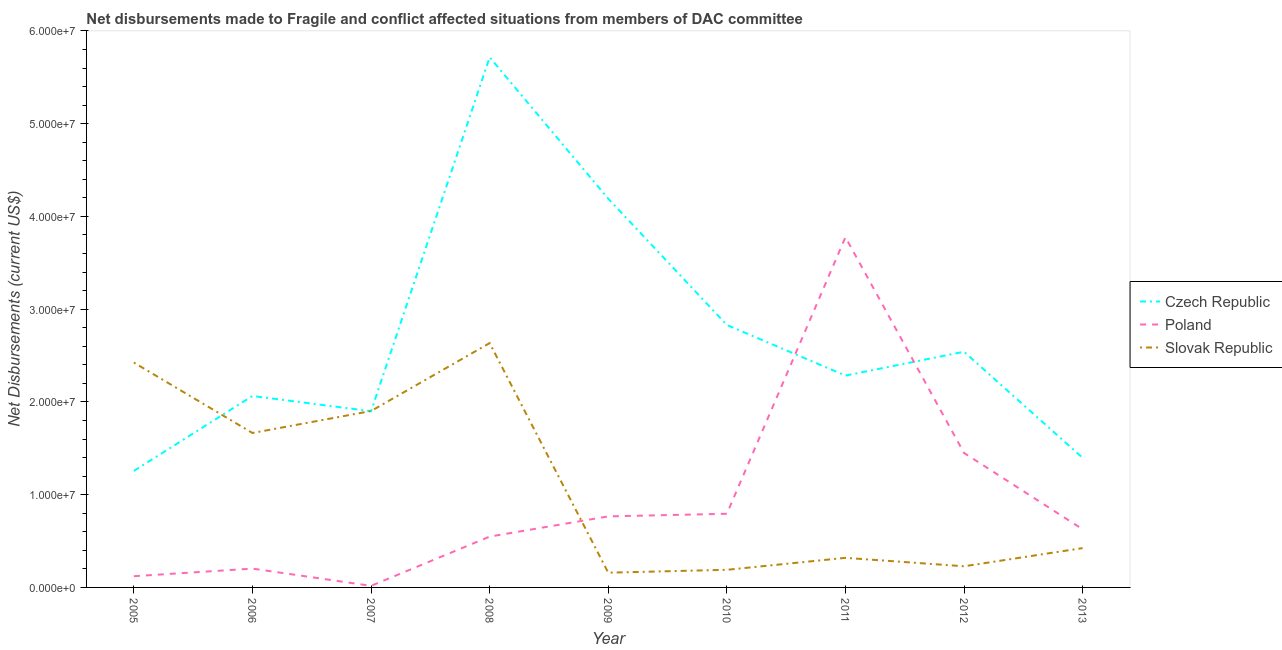How many different coloured lines are there?
Give a very brief answer. 3. Does the line corresponding to net disbursements made by slovak republic intersect with the line corresponding to net disbursements made by poland?
Give a very brief answer. Yes. Is the number of lines equal to the number of legend labels?
Ensure brevity in your answer.  Yes. What is the net disbursements made by slovak republic in 2007?
Your response must be concise. 1.90e+07. Across all years, what is the maximum net disbursements made by poland?
Your answer should be very brief. 3.78e+07. Across all years, what is the minimum net disbursements made by czech republic?
Provide a short and direct response. 1.26e+07. In which year was the net disbursements made by slovak republic maximum?
Your answer should be compact. 2008. What is the total net disbursements made by slovak republic in the graph?
Offer a terse response. 9.94e+07. What is the difference between the net disbursements made by czech republic in 2006 and that in 2007?
Your answer should be compact. 1.64e+06. What is the difference between the net disbursements made by slovak republic in 2008 and the net disbursements made by poland in 2005?
Your answer should be compact. 2.51e+07. What is the average net disbursements made by slovak republic per year?
Your response must be concise. 1.10e+07. In the year 2009, what is the difference between the net disbursements made by poland and net disbursements made by slovak republic?
Your answer should be very brief. 6.07e+06. In how many years, is the net disbursements made by slovak republic greater than 30000000 US$?
Offer a terse response. 0. What is the ratio of the net disbursements made by slovak republic in 2006 to that in 2012?
Offer a terse response. 7.3. What is the difference between the highest and the second highest net disbursements made by slovak republic?
Offer a very short reply. 2.10e+06. What is the difference between the highest and the lowest net disbursements made by czech republic?
Give a very brief answer. 4.46e+07. Is it the case that in every year, the sum of the net disbursements made by czech republic and net disbursements made by poland is greater than the net disbursements made by slovak republic?
Give a very brief answer. No. Is the net disbursements made by poland strictly less than the net disbursements made by czech republic over the years?
Offer a very short reply. No. How many lines are there?
Keep it short and to the point. 3. How many years are there in the graph?
Your response must be concise. 9. Are the values on the major ticks of Y-axis written in scientific E-notation?
Make the answer very short. Yes. Does the graph contain any zero values?
Make the answer very short. No. How are the legend labels stacked?
Keep it short and to the point. Vertical. What is the title of the graph?
Your answer should be very brief. Net disbursements made to Fragile and conflict affected situations from members of DAC committee. What is the label or title of the Y-axis?
Give a very brief answer. Net Disbursements (current US$). What is the Net Disbursements (current US$) of Czech Republic in 2005?
Make the answer very short. 1.26e+07. What is the Net Disbursements (current US$) in Poland in 2005?
Your answer should be compact. 1.21e+06. What is the Net Disbursements (current US$) in Slovak Republic in 2005?
Your answer should be compact. 2.42e+07. What is the Net Disbursements (current US$) in Czech Republic in 2006?
Your answer should be very brief. 2.06e+07. What is the Net Disbursements (current US$) of Poland in 2006?
Make the answer very short. 2.03e+06. What is the Net Disbursements (current US$) of Slovak Republic in 2006?
Give a very brief answer. 1.66e+07. What is the Net Disbursements (current US$) in Czech Republic in 2007?
Your response must be concise. 1.90e+07. What is the Net Disbursements (current US$) of Slovak Republic in 2007?
Ensure brevity in your answer.  1.90e+07. What is the Net Disbursements (current US$) of Czech Republic in 2008?
Your answer should be very brief. 5.72e+07. What is the Net Disbursements (current US$) in Poland in 2008?
Your response must be concise. 5.48e+06. What is the Net Disbursements (current US$) in Slovak Republic in 2008?
Offer a terse response. 2.63e+07. What is the Net Disbursements (current US$) of Czech Republic in 2009?
Your response must be concise. 4.19e+07. What is the Net Disbursements (current US$) of Poland in 2009?
Your response must be concise. 7.66e+06. What is the Net Disbursements (current US$) in Slovak Republic in 2009?
Offer a terse response. 1.59e+06. What is the Net Disbursements (current US$) of Czech Republic in 2010?
Provide a short and direct response. 2.83e+07. What is the Net Disbursements (current US$) of Poland in 2010?
Offer a terse response. 7.94e+06. What is the Net Disbursements (current US$) of Slovak Republic in 2010?
Make the answer very short. 1.90e+06. What is the Net Disbursements (current US$) in Czech Republic in 2011?
Provide a short and direct response. 2.28e+07. What is the Net Disbursements (current US$) in Poland in 2011?
Ensure brevity in your answer.  3.78e+07. What is the Net Disbursements (current US$) of Slovak Republic in 2011?
Offer a very short reply. 3.19e+06. What is the Net Disbursements (current US$) of Czech Republic in 2012?
Your answer should be compact. 2.54e+07. What is the Net Disbursements (current US$) of Poland in 2012?
Your answer should be compact. 1.45e+07. What is the Net Disbursements (current US$) in Slovak Republic in 2012?
Ensure brevity in your answer.  2.28e+06. What is the Net Disbursements (current US$) of Czech Republic in 2013?
Provide a short and direct response. 1.40e+07. What is the Net Disbursements (current US$) of Poland in 2013?
Your answer should be very brief. 6.27e+06. What is the Net Disbursements (current US$) of Slovak Republic in 2013?
Keep it short and to the point. 4.24e+06. Across all years, what is the maximum Net Disbursements (current US$) of Czech Republic?
Give a very brief answer. 5.72e+07. Across all years, what is the maximum Net Disbursements (current US$) in Poland?
Your response must be concise. 3.78e+07. Across all years, what is the maximum Net Disbursements (current US$) in Slovak Republic?
Offer a very short reply. 2.63e+07. Across all years, what is the minimum Net Disbursements (current US$) in Czech Republic?
Offer a terse response. 1.26e+07. Across all years, what is the minimum Net Disbursements (current US$) of Poland?
Your answer should be very brief. 1.70e+05. Across all years, what is the minimum Net Disbursements (current US$) of Slovak Republic?
Provide a short and direct response. 1.59e+06. What is the total Net Disbursements (current US$) of Czech Republic in the graph?
Your answer should be very brief. 2.42e+08. What is the total Net Disbursements (current US$) of Poland in the graph?
Give a very brief answer. 8.30e+07. What is the total Net Disbursements (current US$) in Slovak Republic in the graph?
Provide a succinct answer. 9.94e+07. What is the difference between the Net Disbursements (current US$) of Czech Republic in 2005 and that in 2006?
Keep it short and to the point. -8.08e+06. What is the difference between the Net Disbursements (current US$) in Poland in 2005 and that in 2006?
Offer a terse response. -8.20e+05. What is the difference between the Net Disbursements (current US$) in Slovak Republic in 2005 and that in 2006?
Keep it short and to the point. 7.59e+06. What is the difference between the Net Disbursements (current US$) in Czech Republic in 2005 and that in 2007?
Your answer should be compact. -6.44e+06. What is the difference between the Net Disbursements (current US$) of Poland in 2005 and that in 2007?
Ensure brevity in your answer.  1.04e+06. What is the difference between the Net Disbursements (current US$) in Slovak Republic in 2005 and that in 2007?
Make the answer very short. 5.22e+06. What is the difference between the Net Disbursements (current US$) of Czech Republic in 2005 and that in 2008?
Your answer should be compact. -4.46e+07. What is the difference between the Net Disbursements (current US$) of Poland in 2005 and that in 2008?
Make the answer very short. -4.27e+06. What is the difference between the Net Disbursements (current US$) in Slovak Republic in 2005 and that in 2008?
Provide a succinct answer. -2.10e+06. What is the difference between the Net Disbursements (current US$) in Czech Republic in 2005 and that in 2009?
Your answer should be very brief. -2.94e+07. What is the difference between the Net Disbursements (current US$) in Poland in 2005 and that in 2009?
Offer a terse response. -6.45e+06. What is the difference between the Net Disbursements (current US$) of Slovak Republic in 2005 and that in 2009?
Give a very brief answer. 2.26e+07. What is the difference between the Net Disbursements (current US$) in Czech Republic in 2005 and that in 2010?
Give a very brief answer. -1.57e+07. What is the difference between the Net Disbursements (current US$) of Poland in 2005 and that in 2010?
Your response must be concise. -6.73e+06. What is the difference between the Net Disbursements (current US$) in Slovak Republic in 2005 and that in 2010?
Your answer should be compact. 2.23e+07. What is the difference between the Net Disbursements (current US$) of Czech Republic in 2005 and that in 2011?
Your answer should be very brief. -1.03e+07. What is the difference between the Net Disbursements (current US$) in Poland in 2005 and that in 2011?
Provide a succinct answer. -3.66e+07. What is the difference between the Net Disbursements (current US$) of Slovak Republic in 2005 and that in 2011?
Offer a terse response. 2.10e+07. What is the difference between the Net Disbursements (current US$) in Czech Republic in 2005 and that in 2012?
Offer a very short reply. -1.28e+07. What is the difference between the Net Disbursements (current US$) in Poland in 2005 and that in 2012?
Your response must be concise. -1.33e+07. What is the difference between the Net Disbursements (current US$) in Slovak Republic in 2005 and that in 2012?
Offer a very short reply. 2.20e+07. What is the difference between the Net Disbursements (current US$) in Czech Republic in 2005 and that in 2013?
Keep it short and to the point. -1.41e+06. What is the difference between the Net Disbursements (current US$) of Poland in 2005 and that in 2013?
Give a very brief answer. -5.06e+06. What is the difference between the Net Disbursements (current US$) in Slovak Republic in 2005 and that in 2013?
Offer a very short reply. 2.00e+07. What is the difference between the Net Disbursements (current US$) of Czech Republic in 2006 and that in 2007?
Your answer should be compact. 1.64e+06. What is the difference between the Net Disbursements (current US$) in Poland in 2006 and that in 2007?
Keep it short and to the point. 1.86e+06. What is the difference between the Net Disbursements (current US$) in Slovak Republic in 2006 and that in 2007?
Your answer should be compact. -2.37e+06. What is the difference between the Net Disbursements (current US$) of Czech Republic in 2006 and that in 2008?
Offer a very short reply. -3.65e+07. What is the difference between the Net Disbursements (current US$) in Poland in 2006 and that in 2008?
Provide a succinct answer. -3.45e+06. What is the difference between the Net Disbursements (current US$) in Slovak Republic in 2006 and that in 2008?
Your answer should be compact. -9.69e+06. What is the difference between the Net Disbursements (current US$) of Czech Republic in 2006 and that in 2009?
Keep it short and to the point. -2.13e+07. What is the difference between the Net Disbursements (current US$) in Poland in 2006 and that in 2009?
Your answer should be very brief. -5.63e+06. What is the difference between the Net Disbursements (current US$) in Slovak Republic in 2006 and that in 2009?
Keep it short and to the point. 1.51e+07. What is the difference between the Net Disbursements (current US$) in Czech Republic in 2006 and that in 2010?
Give a very brief answer. -7.66e+06. What is the difference between the Net Disbursements (current US$) in Poland in 2006 and that in 2010?
Ensure brevity in your answer.  -5.91e+06. What is the difference between the Net Disbursements (current US$) in Slovak Republic in 2006 and that in 2010?
Ensure brevity in your answer.  1.48e+07. What is the difference between the Net Disbursements (current US$) in Czech Republic in 2006 and that in 2011?
Offer a terse response. -2.20e+06. What is the difference between the Net Disbursements (current US$) of Poland in 2006 and that in 2011?
Provide a succinct answer. -3.57e+07. What is the difference between the Net Disbursements (current US$) of Slovak Republic in 2006 and that in 2011?
Provide a succinct answer. 1.35e+07. What is the difference between the Net Disbursements (current US$) in Czech Republic in 2006 and that in 2012?
Keep it short and to the point. -4.77e+06. What is the difference between the Net Disbursements (current US$) of Poland in 2006 and that in 2012?
Your response must be concise. -1.25e+07. What is the difference between the Net Disbursements (current US$) in Slovak Republic in 2006 and that in 2012?
Ensure brevity in your answer.  1.44e+07. What is the difference between the Net Disbursements (current US$) in Czech Republic in 2006 and that in 2013?
Ensure brevity in your answer.  6.67e+06. What is the difference between the Net Disbursements (current US$) of Poland in 2006 and that in 2013?
Offer a terse response. -4.24e+06. What is the difference between the Net Disbursements (current US$) in Slovak Republic in 2006 and that in 2013?
Keep it short and to the point. 1.24e+07. What is the difference between the Net Disbursements (current US$) in Czech Republic in 2007 and that in 2008?
Your answer should be very brief. -3.82e+07. What is the difference between the Net Disbursements (current US$) in Poland in 2007 and that in 2008?
Offer a terse response. -5.31e+06. What is the difference between the Net Disbursements (current US$) of Slovak Republic in 2007 and that in 2008?
Provide a short and direct response. -7.32e+06. What is the difference between the Net Disbursements (current US$) in Czech Republic in 2007 and that in 2009?
Your answer should be compact. -2.29e+07. What is the difference between the Net Disbursements (current US$) in Poland in 2007 and that in 2009?
Ensure brevity in your answer.  -7.49e+06. What is the difference between the Net Disbursements (current US$) in Slovak Republic in 2007 and that in 2009?
Provide a short and direct response. 1.74e+07. What is the difference between the Net Disbursements (current US$) in Czech Republic in 2007 and that in 2010?
Your answer should be very brief. -9.30e+06. What is the difference between the Net Disbursements (current US$) in Poland in 2007 and that in 2010?
Give a very brief answer. -7.77e+06. What is the difference between the Net Disbursements (current US$) in Slovak Republic in 2007 and that in 2010?
Provide a succinct answer. 1.71e+07. What is the difference between the Net Disbursements (current US$) of Czech Republic in 2007 and that in 2011?
Provide a succinct answer. -3.84e+06. What is the difference between the Net Disbursements (current US$) of Poland in 2007 and that in 2011?
Ensure brevity in your answer.  -3.76e+07. What is the difference between the Net Disbursements (current US$) of Slovak Republic in 2007 and that in 2011?
Provide a short and direct response. 1.58e+07. What is the difference between the Net Disbursements (current US$) of Czech Republic in 2007 and that in 2012?
Offer a terse response. -6.41e+06. What is the difference between the Net Disbursements (current US$) in Poland in 2007 and that in 2012?
Ensure brevity in your answer.  -1.43e+07. What is the difference between the Net Disbursements (current US$) in Slovak Republic in 2007 and that in 2012?
Provide a short and direct response. 1.67e+07. What is the difference between the Net Disbursements (current US$) of Czech Republic in 2007 and that in 2013?
Provide a succinct answer. 5.03e+06. What is the difference between the Net Disbursements (current US$) of Poland in 2007 and that in 2013?
Offer a very short reply. -6.10e+06. What is the difference between the Net Disbursements (current US$) in Slovak Republic in 2007 and that in 2013?
Your response must be concise. 1.48e+07. What is the difference between the Net Disbursements (current US$) in Czech Republic in 2008 and that in 2009?
Your response must be concise. 1.52e+07. What is the difference between the Net Disbursements (current US$) of Poland in 2008 and that in 2009?
Provide a short and direct response. -2.18e+06. What is the difference between the Net Disbursements (current US$) of Slovak Republic in 2008 and that in 2009?
Offer a very short reply. 2.48e+07. What is the difference between the Net Disbursements (current US$) of Czech Republic in 2008 and that in 2010?
Make the answer very short. 2.89e+07. What is the difference between the Net Disbursements (current US$) in Poland in 2008 and that in 2010?
Your answer should be very brief. -2.46e+06. What is the difference between the Net Disbursements (current US$) in Slovak Republic in 2008 and that in 2010?
Make the answer very short. 2.44e+07. What is the difference between the Net Disbursements (current US$) in Czech Republic in 2008 and that in 2011?
Keep it short and to the point. 3.43e+07. What is the difference between the Net Disbursements (current US$) of Poland in 2008 and that in 2011?
Offer a terse response. -3.23e+07. What is the difference between the Net Disbursements (current US$) of Slovak Republic in 2008 and that in 2011?
Offer a very short reply. 2.32e+07. What is the difference between the Net Disbursements (current US$) in Czech Republic in 2008 and that in 2012?
Your response must be concise. 3.18e+07. What is the difference between the Net Disbursements (current US$) of Poland in 2008 and that in 2012?
Give a very brief answer. -9.02e+06. What is the difference between the Net Disbursements (current US$) of Slovak Republic in 2008 and that in 2012?
Your response must be concise. 2.41e+07. What is the difference between the Net Disbursements (current US$) in Czech Republic in 2008 and that in 2013?
Offer a very short reply. 4.32e+07. What is the difference between the Net Disbursements (current US$) in Poland in 2008 and that in 2013?
Your answer should be very brief. -7.90e+05. What is the difference between the Net Disbursements (current US$) in Slovak Republic in 2008 and that in 2013?
Your answer should be compact. 2.21e+07. What is the difference between the Net Disbursements (current US$) of Czech Republic in 2009 and that in 2010?
Your answer should be very brief. 1.36e+07. What is the difference between the Net Disbursements (current US$) in Poland in 2009 and that in 2010?
Your response must be concise. -2.80e+05. What is the difference between the Net Disbursements (current US$) of Slovak Republic in 2009 and that in 2010?
Ensure brevity in your answer.  -3.10e+05. What is the difference between the Net Disbursements (current US$) of Czech Republic in 2009 and that in 2011?
Your response must be concise. 1.91e+07. What is the difference between the Net Disbursements (current US$) of Poland in 2009 and that in 2011?
Make the answer very short. -3.01e+07. What is the difference between the Net Disbursements (current US$) of Slovak Republic in 2009 and that in 2011?
Provide a succinct answer. -1.60e+06. What is the difference between the Net Disbursements (current US$) of Czech Republic in 2009 and that in 2012?
Keep it short and to the point. 1.65e+07. What is the difference between the Net Disbursements (current US$) in Poland in 2009 and that in 2012?
Ensure brevity in your answer.  -6.84e+06. What is the difference between the Net Disbursements (current US$) in Slovak Republic in 2009 and that in 2012?
Give a very brief answer. -6.90e+05. What is the difference between the Net Disbursements (current US$) in Czech Republic in 2009 and that in 2013?
Ensure brevity in your answer.  2.79e+07. What is the difference between the Net Disbursements (current US$) in Poland in 2009 and that in 2013?
Provide a succinct answer. 1.39e+06. What is the difference between the Net Disbursements (current US$) of Slovak Republic in 2009 and that in 2013?
Provide a short and direct response. -2.65e+06. What is the difference between the Net Disbursements (current US$) of Czech Republic in 2010 and that in 2011?
Your response must be concise. 5.46e+06. What is the difference between the Net Disbursements (current US$) in Poland in 2010 and that in 2011?
Provide a short and direct response. -2.98e+07. What is the difference between the Net Disbursements (current US$) in Slovak Republic in 2010 and that in 2011?
Provide a short and direct response. -1.29e+06. What is the difference between the Net Disbursements (current US$) of Czech Republic in 2010 and that in 2012?
Offer a very short reply. 2.89e+06. What is the difference between the Net Disbursements (current US$) in Poland in 2010 and that in 2012?
Your answer should be compact. -6.56e+06. What is the difference between the Net Disbursements (current US$) of Slovak Republic in 2010 and that in 2012?
Provide a succinct answer. -3.80e+05. What is the difference between the Net Disbursements (current US$) in Czech Republic in 2010 and that in 2013?
Provide a succinct answer. 1.43e+07. What is the difference between the Net Disbursements (current US$) in Poland in 2010 and that in 2013?
Offer a terse response. 1.67e+06. What is the difference between the Net Disbursements (current US$) in Slovak Republic in 2010 and that in 2013?
Make the answer very short. -2.34e+06. What is the difference between the Net Disbursements (current US$) in Czech Republic in 2011 and that in 2012?
Offer a very short reply. -2.57e+06. What is the difference between the Net Disbursements (current US$) of Poland in 2011 and that in 2012?
Offer a very short reply. 2.33e+07. What is the difference between the Net Disbursements (current US$) in Slovak Republic in 2011 and that in 2012?
Your answer should be compact. 9.10e+05. What is the difference between the Net Disbursements (current US$) in Czech Republic in 2011 and that in 2013?
Your answer should be compact. 8.87e+06. What is the difference between the Net Disbursements (current US$) in Poland in 2011 and that in 2013?
Your response must be concise. 3.15e+07. What is the difference between the Net Disbursements (current US$) in Slovak Republic in 2011 and that in 2013?
Make the answer very short. -1.05e+06. What is the difference between the Net Disbursements (current US$) of Czech Republic in 2012 and that in 2013?
Your answer should be very brief. 1.14e+07. What is the difference between the Net Disbursements (current US$) of Poland in 2012 and that in 2013?
Provide a succinct answer. 8.23e+06. What is the difference between the Net Disbursements (current US$) in Slovak Republic in 2012 and that in 2013?
Keep it short and to the point. -1.96e+06. What is the difference between the Net Disbursements (current US$) of Czech Republic in 2005 and the Net Disbursements (current US$) of Poland in 2006?
Offer a very short reply. 1.05e+07. What is the difference between the Net Disbursements (current US$) of Czech Republic in 2005 and the Net Disbursements (current US$) of Slovak Republic in 2006?
Your answer should be very brief. -4.09e+06. What is the difference between the Net Disbursements (current US$) of Poland in 2005 and the Net Disbursements (current US$) of Slovak Republic in 2006?
Ensure brevity in your answer.  -1.54e+07. What is the difference between the Net Disbursements (current US$) of Czech Republic in 2005 and the Net Disbursements (current US$) of Poland in 2007?
Offer a very short reply. 1.24e+07. What is the difference between the Net Disbursements (current US$) of Czech Republic in 2005 and the Net Disbursements (current US$) of Slovak Republic in 2007?
Your response must be concise. -6.46e+06. What is the difference between the Net Disbursements (current US$) in Poland in 2005 and the Net Disbursements (current US$) in Slovak Republic in 2007?
Offer a terse response. -1.78e+07. What is the difference between the Net Disbursements (current US$) in Czech Republic in 2005 and the Net Disbursements (current US$) in Poland in 2008?
Your answer should be compact. 7.08e+06. What is the difference between the Net Disbursements (current US$) in Czech Republic in 2005 and the Net Disbursements (current US$) in Slovak Republic in 2008?
Offer a terse response. -1.38e+07. What is the difference between the Net Disbursements (current US$) in Poland in 2005 and the Net Disbursements (current US$) in Slovak Republic in 2008?
Give a very brief answer. -2.51e+07. What is the difference between the Net Disbursements (current US$) in Czech Republic in 2005 and the Net Disbursements (current US$) in Poland in 2009?
Provide a short and direct response. 4.90e+06. What is the difference between the Net Disbursements (current US$) in Czech Republic in 2005 and the Net Disbursements (current US$) in Slovak Republic in 2009?
Keep it short and to the point. 1.10e+07. What is the difference between the Net Disbursements (current US$) in Poland in 2005 and the Net Disbursements (current US$) in Slovak Republic in 2009?
Ensure brevity in your answer.  -3.80e+05. What is the difference between the Net Disbursements (current US$) in Czech Republic in 2005 and the Net Disbursements (current US$) in Poland in 2010?
Offer a very short reply. 4.62e+06. What is the difference between the Net Disbursements (current US$) in Czech Republic in 2005 and the Net Disbursements (current US$) in Slovak Republic in 2010?
Give a very brief answer. 1.07e+07. What is the difference between the Net Disbursements (current US$) in Poland in 2005 and the Net Disbursements (current US$) in Slovak Republic in 2010?
Make the answer very short. -6.90e+05. What is the difference between the Net Disbursements (current US$) in Czech Republic in 2005 and the Net Disbursements (current US$) in Poland in 2011?
Make the answer very short. -2.52e+07. What is the difference between the Net Disbursements (current US$) of Czech Republic in 2005 and the Net Disbursements (current US$) of Slovak Republic in 2011?
Provide a short and direct response. 9.37e+06. What is the difference between the Net Disbursements (current US$) of Poland in 2005 and the Net Disbursements (current US$) of Slovak Republic in 2011?
Provide a short and direct response. -1.98e+06. What is the difference between the Net Disbursements (current US$) in Czech Republic in 2005 and the Net Disbursements (current US$) in Poland in 2012?
Your answer should be very brief. -1.94e+06. What is the difference between the Net Disbursements (current US$) of Czech Republic in 2005 and the Net Disbursements (current US$) of Slovak Republic in 2012?
Keep it short and to the point. 1.03e+07. What is the difference between the Net Disbursements (current US$) of Poland in 2005 and the Net Disbursements (current US$) of Slovak Republic in 2012?
Offer a terse response. -1.07e+06. What is the difference between the Net Disbursements (current US$) in Czech Republic in 2005 and the Net Disbursements (current US$) in Poland in 2013?
Your response must be concise. 6.29e+06. What is the difference between the Net Disbursements (current US$) of Czech Republic in 2005 and the Net Disbursements (current US$) of Slovak Republic in 2013?
Provide a succinct answer. 8.32e+06. What is the difference between the Net Disbursements (current US$) of Poland in 2005 and the Net Disbursements (current US$) of Slovak Republic in 2013?
Keep it short and to the point. -3.03e+06. What is the difference between the Net Disbursements (current US$) of Czech Republic in 2006 and the Net Disbursements (current US$) of Poland in 2007?
Keep it short and to the point. 2.05e+07. What is the difference between the Net Disbursements (current US$) in Czech Republic in 2006 and the Net Disbursements (current US$) in Slovak Republic in 2007?
Your answer should be very brief. 1.62e+06. What is the difference between the Net Disbursements (current US$) of Poland in 2006 and the Net Disbursements (current US$) of Slovak Republic in 2007?
Provide a short and direct response. -1.70e+07. What is the difference between the Net Disbursements (current US$) of Czech Republic in 2006 and the Net Disbursements (current US$) of Poland in 2008?
Offer a terse response. 1.52e+07. What is the difference between the Net Disbursements (current US$) of Czech Republic in 2006 and the Net Disbursements (current US$) of Slovak Republic in 2008?
Offer a very short reply. -5.70e+06. What is the difference between the Net Disbursements (current US$) of Poland in 2006 and the Net Disbursements (current US$) of Slovak Republic in 2008?
Your answer should be very brief. -2.43e+07. What is the difference between the Net Disbursements (current US$) of Czech Republic in 2006 and the Net Disbursements (current US$) of Poland in 2009?
Your answer should be compact. 1.30e+07. What is the difference between the Net Disbursements (current US$) of Czech Republic in 2006 and the Net Disbursements (current US$) of Slovak Republic in 2009?
Your answer should be compact. 1.90e+07. What is the difference between the Net Disbursements (current US$) of Czech Republic in 2006 and the Net Disbursements (current US$) of Poland in 2010?
Offer a very short reply. 1.27e+07. What is the difference between the Net Disbursements (current US$) of Czech Republic in 2006 and the Net Disbursements (current US$) of Slovak Republic in 2010?
Your response must be concise. 1.87e+07. What is the difference between the Net Disbursements (current US$) in Poland in 2006 and the Net Disbursements (current US$) in Slovak Republic in 2010?
Offer a terse response. 1.30e+05. What is the difference between the Net Disbursements (current US$) in Czech Republic in 2006 and the Net Disbursements (current US$) in Poland in 2011?
Your answer should be compact. -1.71e+07. What is the difference between the Net Disbursements (current US$) in Czech Republic in 2006 and the Net Disbursements (current US$) in Slovak Republic in 2011?
Your answer should be compact. 1.74e+07. What is the difference between the Net Disbursements (current US$) in Poland in 2006 and the Net Disbursements (current US$) in Slovak Republic in 2011?
Your answer should be compact. -1.16e+06. What is the difference between the Net Disbursements (current US$) of Czech Republic in 2006 and the Net Disbursements (current US$) of Poland in 2012?
Keep it short and to the point. 6.14e+06. What is the difference between the Net Disbursements (current US$) in Czech Republic in 2006 and the Net Disbursements (current US$) in Slovak Republic in 2012?
Offer a terse response. 1.84e+07. What is the difference between the Net Disbursements (current US$) in Czech Republic in 2006 and the Net Disbursements (current US$) in Poland in 2013?
Make the answer very short. 1.44e+07. What is the difference between the Net Disbursements (current US$) in Czech Republic in 2006 and the Net Disbursements (current US$) in Slovak Republic in 2013?
Ensure brevity in your answer.  1.64e+07. What is the difference between the Net Disbursements (current US$) in Poland in 2006 and the Net Disbursements (current US$) in Slovak Republic in 2013?
Give a very brief answer. -2.21e+06. What is the difference between the Net Disbursements (current US$) of Czech Republic in 2007 and the Net Disbursements (current US$) of Poland in 2008?
Provide a succinct answer. 1.35e+07. What is the difference between the Net Disbursements (current US$) in Czech Republic in 2007 and the Net Disbursements (current US$) in Slovak Republic in 2008?
Make the answer very short. -7.34e+06. What is the difference between the Net Disbursements (current US$) of Poland in 2007 and the Net Disbursements (current US$) of Slovak Republic in 2008?
Give a very brief answer. -2.62e+07. What is the difference between the Net Disbursements (current US$) in Czech Republic in 2007 and the Net Disbursements (current US$) in Poland in 2009?
Give a very brief answer. 1.13e+07. What is the difference between the Net Disbursements (current US$) of Czech Republic in 2007 and the Net Disbursements (current US$) of Slovak Republic in 2009?
Give a very brief answer. 1.74e+07. What is the difference between the Net Disbursements (current US$) of Poland in 2007 and the Net Disbursements (current US$) of Slovak Republic in 2009?
Your answer should be very brief. -1.42e+06. What is the difference between the Net Disbursements (current US$) in Czech Republic in 2007 and the Net Disbursements (current US$) in Poland in 2010?
Your response must be concise. 1.11e+07. What is the difference between the Net Disbursements (current US$) of Czech Republic in 2007 and the Net Disbursements (current US$) of Slovak Republic in 2010?
Offer a terse response. 1.71e+07. What is the difference between the Net Disbursements (current US$) in Poland in 2007 and the Net Disbursements (current US$) in Slovak Republic in 2010?
Your answer should be very brief. -1.73e+06. What is the difference between the Net Disbursements (current US$) in Czech Republic in 2007 and the Net Disbursements (current US$) in Poland in 2011?
Your response must be concise. -1.88e+07. What is the difference between the Net Disbursements (current US$) in Czech Republic in 2007 and the Net Disbursements (current US$) in Slovak Republic in 2011?
Keep it short and to the point. 1.58e+07. What is the difference between the Net Disbursements (current US$) of Poland in 2007 and the Net Disbursements (current US$) of Slovak Republic in 2011?
Provide a short and direct response. -3.02e+06. What is the difference between the Net Disbursements (current US$) of Czech Republic in 2007 and the Net Disbursements (current US$) of Poland in 2012?
Make the answer very short. 4.50e+06. What is the difference between the Net Disbursements (current US$) of Czech Republic in 2007 and the Net Disbursements (current US$) of Slovak Republic in 2012?
Ensure brevity in your answer.  1.67e+07. What is the difference between the Net Disbursements (current US$) of Poland in 2007 and the Net Disbursements (current US$) of Slovak Republic in 2012?
Your answer should be compact. -2.11e+06. What is the difference between the Net Disbursements (current US$) in Czech Republic in 2007 and the Net Disbursements (current US$) in Poland in 2013?
Offer a very short reply. 1.27e+07. What is the difference between the Net Disbursements (current US$) of Czech Republic in 2007 and the Net Disbursements (current US$) of Slovak Republic in 2013?
Ensure brevity in your answer.  1.48e+07. What is the difference between the Net Disbursements (current US$) of Poland in 2007 and the Net Disbursements (current US$) of Slovak Republic in 2013?
Your response must be concise. -4.07e+06. What is the difference between the Net Disbursements (current US$) in Czech Republic in 2008 and the Net Disbursements (current US$) in Poland in 2009?
Your answer should be compact. 4.95e+07. What is the difference between the Net Disbursements (current US$) in Czech Republic in 2008 and the Net Disbursements (current US$) in Slovak Republic in 2009?
Ensure brevity in your answer.  5.56e+07. What is the difference between the Net Disbursements (current US$) of Poland in 2008 and the Net Disbursements (current US$) of Slovak Republic in 2009?
Ensure brevity in your answer.  3.89e+06. What is the difference between the Net Disbursements (current US$) in Czech Republic in 2008 and the Net Disbursements (current US$) in Poland in 2010?
Your answer should be compact. 4.92e+07. What is the difference between the Net Disbursements (current US$) in Czech Republic in 2008 and the Net Disbursements (current US$) in Slovak Republic in 2010?
Give a very brief answer. 5.53e+07. What is the difference between the Net Disbursements (current US$) of Poland in 2008 and the Net Disbursements (current US$) of Slovak Republic in 2010?
Offer a very short reply. 3.58e+06. What is the difference between the Net Disbursements (current US$) in Czech Republic in 2008 and the Net Disbursements (current US$) in Poland in 2011?
Provide a succinct answer. 1.94e+07. What is the difference between the Net Disbursements (current US$) in Czech Republic in 2008 and the Net Disbursements (current US$) in Slovak Republic in 2011?
Ensure brevity in your answer.  5.40e+07. What is the difference between the Net Disbursements (current US$) of Poland in 2008 and the Net Disbursements (current US$) of Slovak Republic in 2011?
Make the answer very short. 2.29e+06. What is the difference between the Net Disbursements (current US$) in Czech Republic in 2008 and the Net Disbursements (current US$) in Poland in 2012?
Offer a very short reply. 4.27e+07. What is the difference between the Net Disbursements (current US$) of Czech Republic in 2008 and the Net Disbursements (current US$) of Slovak Republic in 2012?
Make the answer very short. 5.49e+07. What is the difference between the Net Disbursements (current US$) of Poland in 2008 and the Net Disbursements (current US$) of Slovak Republic in 2012?
Make the answer very short. 3.20e+06. What is the difference between the Net Disbursements (current US$) of Czech Republic in 2008 and the Net Disbursements (current US$) of Poland in 2013?
Your answer should be very brief. 5.09e+07. What is the difference between the Net Disbursements (current US$) in Czech Republic in 2008 and the Net Disbursements (current US$) in Slovak Republic in 2013?
Ensure brevity in your answer.  5.29e+07. What is the difference between the Net Disbursements (current US$) in Poland in 2008 and the Net Disbursements (current US$) in Slovak Republic in 2013?
Offer a very short reply. 1.24e+06. What is the difference between the Net Disbursements (current US$) of Czech Republic in 2009 and the Net Disbursements (current US$) of Poland in 2010?
Offer a terse response. 3.40e+07. What is the difference between the Net Disbursements (current US$) in Czech Republic in 2009 and the Net Disbursements (current US$) in Slovak Republic in 2010?
Provide a succinct answer. 4.00e+07. What is the difference between the Net Disbursements (current US$) in Poland in 2009 and the Net Disbursements (current US$) in Slovak Republic in 2010?
Your answer should be very brief. 5.76e+06. What is the difference between the Net Disbursements (current US$) of Czech Republic in 2009 and the Net Disbursements (current US$) of Poland in 2011?
Give a very brief answer. 4.15e+06. What is the difference between the Net Disbursements (current US$) in Czech Republic in 2009 and the Net Disbursements (current US$) in Slovak Republic in 2011?
Offer a terse response. 3.87e+07. What is the difference between the Net Disbursements (current US$) of Poland in 2009 and the Net Disbursements (current US$) of Slovak Republic in 2011?
Your answer should be compact. 4.47e+06. What is the difference between the Net Disbursements (current US$) in Czech Republic in 2009 and the Net Disbursements (current US$) in Poland in 2012?
Ensure brevity in your answer.  2.74e+07. What is the difference between the Net Disbursements (current US$) of Czech Republic in 2009 and the Net Disbursements (current US$) of Slovak Republic in 2012?
Provide a succinct answer. 3.96e+07. What is the difference between the Net Disbursements (current US$) in Poland in 2009 and the Net Disbursements (current US$) in Slovak Republic in 2012?
Give a very brief answer. 5.38e+06. What is the difference between the Net Disbursements (current US$) of Czech Republic in 2009 and the Net Disbursements (current US$) of Poland in 2013?
Offer a terse response. 3.56e+07. What is the difference between the Net Disbursements (current US$) in Czech Republic in 2009 and the Net Disbursements (current US$) in Slovak Republic in 2013?
Keep it short and to the point. 3.77e+07. What is the difference between the Net Disbursements (current US$) in Poland in 2009 and the Net Disbursements (current US$) in Slovak Republic in 2013?
Provide a succinct answer. 3.42e+06. What is the difference between the Net Disbursements (current US$) of Czech Republic in 2010 and the Net Disbursements (current US$) of Poland in 2011?
Your response must be concise. -9.46e+06. What is the difference between the Net Disbursements (current US$) in Czech Republic in 2010 and the Net Disbursements (current US$) in Slovak Republic in 2011?
Offer a very short reply. 2.51e+07. What is the difference between the Net Disbursements (current US$) in Poland in 2010 and the Net Disbursements (current US$) in Slovak Republic in 2011?
Give a very brief answer. 4.75e+06. What is the difference between the Net Disbursements (current US$) of Czech Republic in 2010 and the Net Disbursements (current US$) of Poland in 2012?
Keep it short and to the point. 1.38e+07. What is the difference between the Net Disbursements (current US$) in Czech Republic in 2010 and the Net Disbursements (current US$) in Slovak Republic in 2012?
Make the answer very short. 2.60e+07. What is the difference between the Net Disbursements (current US$) of Poland in 2010 and the Net Disbursements (current US$) of Slovak Republic in 2012?
Keep it short and to the point. 5.66e+06. What is the difference between the Net Disbursements (current US$) in Czech Republic in 2010 and the Net Disbursements (current US$) in Poland in 2013?
Ensure brevity in your answer.  2.20e+07. What is the difference between the Net Disbursements (current US$) in Czech Republic in 2010 and the Net Disbursements (current US$) in Slovak Republic in 2013?
Your response must be concise. 2.41e+07. What is the difference between the Net Disbursements (current US$) in Poland in 2010 and the Net Disbursements (current US$) in Slovak Republic in 2013?
Your response must be concise. 3.70e+06. What is the difference between the Net Disbursements (current US$) of Czech Republic in 2011 and the Net Disbursements (current US$) of Poland in 2012?
Provide a succinct answer. 8.34e+06. What is the difference between the Net Disbursements (current US$) in Czech Republic in 2011 and the Net Disbursements (current US$) in Slovak Republic in 2012?
Offer a terse response. 2.06e+07. What is the difference between the Net Disbursements (current US$) of Poland in 2011 and the Net Disbursements (current US$) of Slovak Republic in 2012?
Provide a succinct answer. 3.55e+07. What is the difference between the Net Disbursements (current US$) of Czech Republic in 2011 and the Net Disbursements (current US$) of Poland in 2013?
Your answer should be very brief. 1.66e+07. What is the difference between the Net Disbursements (current US$) of Czech Republic in 2011 and the Net Disbursements (current US$) of Slovak Republic in 2013?
Your answer should be very brief. 1.86e+07. What is the difference between the Net Disbursements (current US$) of Poland in 2011 and the Net Disbursements (current US$) of Slovak Republic in 2013?
Provide a short and direct response. 3.35e+07. What is the difference between the Net Disbursements (current US$) of Czech Republic in 2012 and the Net Disbursements (current US$) of Poland in 2013?
Your answer should be compact. 1.91e+07. What is the difference between the Net Disbursements (current US$) in Czech Republic in 2012 and the Net Disbursements (current US$) in Slovak Republic in 2013?
Your answer should be compact. 2.12e+07. What is the difference between the Net Disbursements (current US$) of Poland in 2012 and the Net Disbursements (current US$) of Slovak Republic in 2013?
Ensure brevity in your answer.  1.03e+07. What is the average Net Disbursements (current US$) of Czech Republic per year?
Your answer should be compact. 2.69e+07. What is the average Net Disbursements (current US$) of Poland per year?
Offer a terse response. 9.22e+06. What is the average Net Disbursements (current US$) of Slovak Republic per year?
Provide a short and direct response. 1.10e+07. In the year 2005, what is the difference between the Net Disbursements (current US$) in Czech Republic and Net Disbursements (current US$) in Poland?
Your answer should be compact. 1.14e+07. In the year 2005, what is the difference between the Net Disbursements (current US$) of Czech Republic and Net Disbursements (current US$) of Slovak Republic?
Your answer should be compact. -1.17e+07. In the year 2005, what is the difference between the Net Disbursements (current US$) in Poland and Net Disbursements (current US$) in Slovak Republic?
Your answer should be compact. -2.30e+07. In the year 2006, what is the difference between the Net Disbursements (current US$) in Czech Republic and Net Disbursements (current US$) in Poland?
Offer a terse response. 1.86e+07. In the year 2006, what is the difference between the Net Disbursements (current US$) in Czech Republic and Net Disbursements (current US$) in Slovak Republic?
Offer a terse response. 3.99e+06. In the year 2006, what is the difference between the Net Disbursements (current US$) of Poland and Net Disbursements (current US$) of Slovak Republic?
Offer a very short reply. -1.46e+07. In the year 2007, what is the difference between the Net Disbursements (current US$) in Czech Republic and Net Disbursements (current US$) in Poland?
Your answer should be very brief. 1.88e+07. In the year 2007, what is the difference between the Net Disbursements (current US$) of Poland and Net Disbursements (current US$) of Slovak Republic?
Make the answer very short. -1.88e+07. In the year 2008, what is the difference between the Net Disbursements (current US$) of Czech Republic and Net Disbursements (current US$) of Poland?
Your response must be concise. 5.17e+07. In the year 2008, what is the difference between the Net Disbursements (current US$) of Czech Republic and Net Disbursements (current US$) of Slovak Republic?
Provide a short and direct response. 3.08e+07. In the year 2008, what is the difference between the Net Disbursements (current US$) in Poland and Net Disbursements (current US$) in Slovak Republic?
Keep it short and to the point. -2.09e+07. In the year 2009, what is the difference between the Net Disbursements (current US$) of Czech Republic and Net Disbursements (current US$) of Poland?
Offer a very short reply. 3.42e+07. In the year 2009, what is the difference between the Net Disbursements (current US$) of Czech Republic and Net Disbursements (current US$) of Slovak Republic?
Your answer should be very brief. 4.03e+07. In the year 2009, what is the difference between the Net Disbursements (current US$) of Poland and Net Disbursements (current US$) of Slovak Republic?
Provide a succinct answer. 6.07e+06. In the year 2010, what is the difference between the Net Disbursements (current US$) in Czech Republic and Net Disbursements (current US$) in Poland?
Your answer should be very brief. 2.04e+07. In the year 2010, what is the difference between the Net Disbursements (current US$) of Czech Republic and Net Disbursements (current US$) of Slovak Republic?
Give a very brief answer. 2.64e+07. In the year 2010, what is the difference between the Net Disbursements (current US$) in Poland and Net Disbursements (current US$) in Slovak Republic?
Your answer should be very brief. 6.04e+06. In the year 2011, what is the difference between the Net Disbursements (current US$) in Czech Republic and Net Disbursements (current US$) in Poland?
Your response must be concise. -1.49e+07. In the year 2011, what is the difference between the Net Disbursements (current US$) of Czech Republic and Net Disbursements (current US$) of Slovak Republic?
Your answer should be compact. 1.96e+07. In the year 2011, what is the difference between the Net Disbursements (current US$) of Poland and Net Disbursements (current US$) of Slovak Republic?
Give a very brief answer. 3.46e+07. In the year 2012, what is the difference between the Net Disbursements (current US$) in Czech Republic and Net Disbursements (current US$) in Poland?
Your response must be concise. 1.09e+07. In the year 2012, what is the difference between the Net Disbursements (current US$) of Czech Republic and Net Disbursements (current US$) of Slovak Republic?
Offer a terse response. 2.31e+07. In the year 2012, what is the difference between the Net Disbursements (current US$) in Poland and Net Disbursements (current US$) in Slovak Republic?
Keep it short and to the point. 1.22e+07. In the year 2013, what is the difference between the Net Disbursements (current US$) in Czech Republic and Net Disbursements (current US$) in Poland?
Make the answer very short. 7.70e+06. In the year 2013, what is the difference between the Net Disbursements (current US$) in Czech Republic and Net Disbursements (current US$) in Slovak Republic?
Your answer should be very brief. 9.73e+06. In the year 2013, what is the difference between the Net Disbursements (current US$) in Poland and Net Disbursements (current US$) in Slovak Republic?
Your response must be concise. 2.03e+06. What is the ratio of the Net Disbursements (current US$) of Czech Republic in 2005 to that in 2006?
Your answer should be very brief. 0.61. What is the ratio of the Net Disbursements (current US$) in Poland in 2005 to that in 2006?
Give a very brief answer. 0.6. What is the ratio of the Net Disbursements (current US$) in Slovak Republic in 2005 to that in 2006?
Provide a succinct answer. 1.46. What is the ratio of the Net Disbursements (current US$) of Czech Republic in 2005 to that in 2007?
Provide a succinct answer. 0.66. What is the ratio of the Net Disbursements (current US$) of Poland in 2005 to that in 2007?
Your response must be concise. 7.12. What is the ratio of the Net Disbursements (current US$) of Slovak Republic in 2005 to that in 2007?
Your response must be concise. 1.27. What is the ratio of the Net Disbursements (current US$) of Czech Republic in 2005 to that in 2008?
Provide a short and direct response. 0.22. What is the ratio of the Net Disbursements (current US$) of Poland in 2005 to that in 2008?
Make the answer very short. 0.22. What is the ratio of the Net Disbursements (current US$) of Slovak Republic in 2005 to that in 2008?
Keep it short and to the point. 0.92. What is the ratio of the Net Disbursements (current US$) of Czech Republic in 2005 to that in 2009?
Give a very brief answer. 0.3. What is the ratio of the Net Disbursements (current US$) of Poland in 2005 to that in 2009?
Ensure brevity in your answer.  0.16. What is the ratio of the Net Disbursements (current US$) of Slovak Republic in 2005 to that in 2009?
Your response must be concise. 15.25. What is the ratio of the Net Disbursements (current US$) of Czech Republic in 2005 to that in 2010?
Offer a terse response. 0.44. What is the ratio of the Net Disbursements (current US$) in Poland in 2005 to that in 2010?
Give a very brief answer. 0.15. What is the ratio of the Net Disbursements (current US$) in Slovak Republic in 2005 to that in 2010?
Give a very brief answer. 12.76. What is the ratio of the Net Disbursements (current US$) of Czech Republic in 2005 to that in 2011?
Keep it short and to the point. 0.55. What is the ratio of the Net Disbursements (current US$) of Poland in 2005 to that in 2011?
Your answer should be very brief. 0.03. What is the ratio of the Net Disbursements (current US$) in Slovak Republic in 2005 to that in 2011?
Keep it short and to the point. 7.6. What is the ratio of the Net Disbursements (current US$) of Czech Republic in 2005 to that in 2012?
Offer a very short reply. 0.49. What is the ratio of the Net Disbursements (current US$) of Poland in 2005 to that in 2012?
Your response must be concise. 0.08. What is the ratio of the Net Disbursements (current US$) in Slovak Republic in 2005 to that in 2012?
Offer a very short reply. 10.63. What is the ratio of the Net Disbursements (current US$) in Czech Republic in 2005 to that in 2013?
Your response must be concise. 0.9. What is the ratio of the Net Disbursements (current US$) in Poland in 2005 to that in 2013?
Your answer should be very brief. 0.19. What is the ratio of the Net Disbursements (current US$) in Slovak Republic in 2005 to that in 2013?
Offer a very short reply. 5.72. What is the ratio of the Net Disbursements (current US$) of Czech Republic in 2006 to that in 2007?
Your response must be concise. 1.09. What is the ratio of the Net Disbursements (current US$) of Poland in 2006 to that in 2007?
Keep it short and to the point. 11.94. What is the ratio of the Net Disbursements (current US$) of Slovak Republic in 2006 to that in 2007?
Ensure brevity in your answer.  0.88. What is the ratio of the Net Disbursements (current US$) in Czech Republic in 2006 to that in 2008?
Your answer should be very brief. 0.36. What is the ratio of the Net Disbursements (current US$) in Poland in 2006 to that in 2008?
Provide a succinct answer. 0.37. What is the ratio of the Net Disbursements (current US$) of Slovak Republic in 2006 to that in 2008?
Offer a terse response. 0.63. What is the ratio of the Net Disbursements (current US$) in Czech Republic in 2006 to that in 2009?
Give a very brief answer. 0.49. What is the ratio of the Net Disbursements (current US$) in Poland in 2006 to that in 2009?
Your answer should be compact. 0.27. What is the ratio of the Net Disbursements (current US$) of Slovak Republic in 2006 to that in 2009?
Provide a succinct answer. 10.47. What is the ratio of the Net Disbursements (current US$) in Czech Republic in 2006 to that in 2010?
Provide a short and direct response. 0.73. What is the ratio of the Net Disbursements (current US$) in Poland in 2006 to that in 2010?
Provide a succinct answer. 0.26. What is the ratio of the Net Disbursements (current US$) of Slovak Republic in 2006 to that in 2010?
Your answer should be very brief. 8.76. What is the ratio of the Net Disbursements (current US$) of Czech Republic in 2006 to that in 2011?
Offer a terse response. 0.9. What is the ratio of the Net Disbursements (current US$) in Poland in 2006 to that in 2011?
Your response must be concise. 0.05. What is the ratio of the Net Disbursements (current US$) in Slovak Republic in 2006 to that in 2011?
Make the answer very short. 5.22. What is the ratio of the Net Disbursements (current US$) of Czech Republic in 2006 to that in 2012?
Give a very brief answer. 0.81. What is the ratio of the Net Disbursements (current US$) in Poland in 2006 to that in 2012?
Your answer should be very brief. 0.14. What is the ratio of the Net Disbursements (current US$) in Slovak Republic in 2006 to that in 2012?
Keep it short and to the point. 7.3. What is the ratio of the Net Disbursements (current US$) in Czech Republic in 2006 to that in 2013?
Your response must be concise. 1.48. What is the ratio of the Net Disbursements (current US$) in Poland in 2006 to that in 2013?
Give a very brief answer. 0.32. What is the ratio of the Net Disbursements (current US$) in Slovak Republic in 2006 to that in 2013?
Provide a succinct answer. 3.93. What is the ratio of the Net Disbursements (current US$) in Czech Republic in 2007 to that in 2008?
Your response must be concise. 0.33. What is the ratio of the Net Disbursements (current US$) of Poland in 2007 to that in 2008?
Give a very brief answer. 0.03. What is the ratio of the Net Disbursements (current US$) in Slovak Republic in 2007 to that in 2008?
Your response must be concise. 0.72. What is the ratio of the Net Disbursements (current US$) in Czech Republic in 2007 to that in 2009?
Make the answer very short. 0.45. What is the ratio of the Net Disbursements (current US$) of Poland in 2007 to that in 2009?
Provide a short and direct response. 0.02. What is the ratio of the Net Disbursements (current US$) in Slovak Republic in 2007 to that in 2009?
Offer a terse response. 11.96. What is the ratio of the Net Disbursements (current US$) of Czech Republic in 2007 to that in 2010?
Provide a succinct answer. 0.67. What is the ratio of the Net Disbursements (current US$) of Poland in 2007 to that in 2010?
Your answer should be compact. 0.02. What is the ratio of the Net Disbursements (current US$) in Slovak Republic in 2007 to that in 2010?
Provide a succinct answer. 10.01. What is the ratio of the Net Disbursements (current US$) in Czech Republic in 2007 to that in 2011?
Provide a short and direct response. 0.83. What is the ratio of the Net Disbursements (current US$) in Poland in 2007 to that in 2011?
Offer a terse response. 0. What is the ratio of the Net Disbursements (current US$) of Slovak Republic in 2007 to that in 2011?
Keep it short and to the point. 5.96. What is the ratio of the Net Disbursements (current US$) of Czech Republic in 2007 to that in 2012?
Ensure brevity in your answer.  0.75. What is the ratio of the Net Disbursements (current US$) of Poland in 2007 to that in 2012?
Offer a very short reply. 0.01. What is the ratio of the Net Disbursements (current US$) of Slovak Republic in 2007 to that in 2012?
Ensure brevity in your answer.  8.34. What is the ratio of the Net Disbursements (current US$) in Czech Republic in 2007 to that in 2013?
Give a very brief answer. 1.36. What is the ratio of the Net Disbursements (current US$) in Poland in 2007 to that in 2013?
Provide a short and direct response. 0.03. What is the ratio of the Net Disbursements (current US$) of Slovak Republic in 2007 to that in 2013?
Ensure brevity in your answer.  4.49. What is the ratio of the Net Disbursements (current US$) in Czech Republic in 2008 to that in 2009?
Ensure brevity in your answer.  1.36. What is the ratio of the Net Disbursements (current US$) in Poland in 2008 to that in 2009?
Offer a terse response. 0.72. What is the ratio of the Net Disbursements (current US$) in Slovak Republic in 2008 to that in 2009?
Offer a very short reply. 16.57. What is the ratio of the Net Disbursements (current US$) of Czech Republic in 2008 to that in 2010?
Make the answer very short. 2.02. What is the ratio of the Net Disbursements (current US$) in Poland in 2008 to that in 2010?
Your response must be concise. 0.69. What is the ratio of the Net Disbursements (current US$) in Slovak Republic in 2008 to that in 2010?
Ensure brevity in your answer.  13.86. What is the ratio of the Net Disbursements (current US$) of Czech Republic in 2008 to that in 2011?
Your answer should be very brief. 2.5. What is the ratio of the Net Disbursements (current US$) of Poland in 2008 to that in 2011?
Provide a short and direct response. 0.15. What is the ratio of the Net Disbursements (current US$) of Slovak Republic in 2008 to that in 2011?
Offer a terse response. 8.26. What is the ratio of the Net Disbursements (current US$) of Czech Republic in 2008 to that in 2012?
Your response must be concise. 2.25. What is the ratio of the Net Disbursements (current US$) of Poland in 2008 to that in 2012?
Your answer should be very brief. 0.38. What is the ratio of the Net Disbursements (current US$) in Slovak Republic in 2008 to that in 2012?
Keep it short and to the point. 11.55. What is the ratio of the Net Disbursements (current US$) in Czech Republic in 2008 to that in 2013?
Make the answer very short. 4.09. What is the ratio of the Net Disbursements (current US$) of Poland in 2008 to that in 2013?
Make the answer very short. 0.87. What is the ratio of the Net Disbursements (current US$) of Slovak Republic in 2008 to that in 2013?
Your answer should be very brief. 6.21. What is the ratio of the Net Disbursements (current US$) in Czech Republic in 2009 to that in 2010?
Provide a succinct answer. 1.48. What is the ratio of the Net Disbursements (current US$) of Poland in 2009 to that in 2010?
Give a very brief answer. 0.96. What is the ratio of the Net Disbursements (current US$) of Slovak Republic in 2009 to that in 2010?
Your answer should be compact. 0.84. What is the ratio of the Net Disbursements (current US$) of Czech Republic in 2009 to that in 2011?
Your answer should be very brief. 1.83. What is the ratio of the Net Disbursements (current US$) of Poland in 2009 to that in 2011?
Your answer should be very brief. 0.2. What is the ratio of the Net Disbursements (current US$) of Slovak Republic in 2009 to that in 2011?
Your answer should be compact. 0.5. What is the ratio of the Net Disbursements (current US$) of Czech Republic in 2009 to that in 2012?
Ensure brevity in your answer.  1.65. What is the ratio of the Net Disbursements (current US$) in Poland in 2009 to that in 2012?
Give a very brief answer. 0.53. What is the ratio of the Net Disbursements (current US$) of Slovak Republic in 2009 to that in 2012?
Keep it short and to the point. 0.7. What is the ratio of the Net Disbursements (current US$) in Poland in 2009 to that in 2013?
Make the answer very short. 1.22. What is the ratio of the Net Disbursements (current US$) in Slovak Republic in 2009 to that in 2013?
Keep it short and to the point. 0.38. What is the ratio of the Net Disbursements (current US$) of Czech Republic in 2010 to that in 2011?
Offer a terse response. 1.24. What is the ratio of the Net Disbursements (current US$) in Poland in 2010 to that in 2011?
Provide a short and direct response. 0.21. What is the ratio of the Net Disbursements (current US$) in Slovak Republic in 2010 to that in 2011?
Make the answer very short. 0.6. What is the ratio of the Net Disbursements (current US$) in Czech Republic in 2010 to that in 2012?
Ensure brevity in your answer.  1.11. What is the ratio of the Net Disbursements (current US$) of Poland in 2010 to that in 2012?
Your answer should be very brief. 0.55. What is the ratio of the Net Disbursements (current US$) in Slovak Republic in 2010 to that in 2012?
Provide a short and direct response. 0.83. What is the ratio of the Net Disbursements (current US$) in Czech Republic in 2010 to that in 2013?
Your answer should be compact. 2.03. What is the ratio of the Net Disbursements (current US$) in Poland in 2010 to that in 2013?
Your answer should be compact. 1.27. What is the ratio of the Net Disbursements (current US$) in Slovak Republic in 2010 to that in 2013?
Your response must be concise. 0.45. What is the ratio of the Net Disbursements (current US$) of Czech Republic in 2011 to that in 2012?
Give a very brief answer. 0.9. What is the ratio of the Net Disbursements (current US$) in Poland in 2011 to that in 2012?
Your answer should be compact. 2.6. What is the ratio of the Net Disbursements (current US$) in Slovak Republic in 2011 to that in 2012?
Your answer should be very brief. 1.4. What is the ratio of the Net Disbursements (current US$) in Czech Republic in 2011 to that in 2013?
Offer a very short reply. 1.63. What is the ratio of the Net Disbursements (current US$) of Poland in 2011 to that in 2013?
Ensure brevity in your answer.  6.02. What is the ratio of the Net Disbursements (current US$) in Slovak Republic in 2011 to that in 2013?
Your answer should be compact. 0.75. What is the ratio of the Net Disbursements (current US$) in Czech Republic in 2012 to that in 2013?
Offer a terse response. 1.82. What is the ratio of the Net Disbursements (current US$) in Poland in 2012 to that in 2013?
Keep it short and to the point. 2.31. What is the ratio of the Net Disbursements (current US$) in Slovak Republic in 2012 to that in 2013?
Offer a terse response. 0.54. What is the difference between the highest and the second highest Net Disbursements (current US$) in Czech Republic?
Give a very brief answer. 1.52e+07. What is the difference between the highest and the second highest Net Disbursements (current US$) of Poland?
Provide a short and direct response. 2.33e+07. What is the difference between the highest and the second highest Net Disbursements (current US$) in Slovak Republic?
Keep it short and to the point. 2.10e+06. What is the difference between the highest and the lowest Net Disbursements (current US$) in Czech Republic?
Your answer should be very brief. 4.46e+07. What is the difference between the highest and the lowest Net Disbursements (current US$) of Poland?
Give a very brief answer. 3.76e+07. What is the difference between the highest and the lowest Net Disbursements (current US$) of Slovak Republic?
Provide a short and direct response. 2.48e+07. 